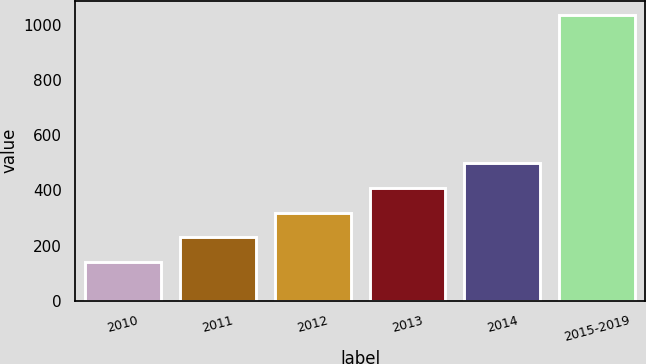<chart> <loc_0><loc_0><loc_500><loc_500><bar_chart><fcel>2010<fcel>2011<fcel>2012<fcel>2013<fcel>2014<fcel>2015-2019<nl><fcel>141<fcel>230.5<fcel>320<fcel>409.5<fcel>499<fcel>1036<nl></chart> 